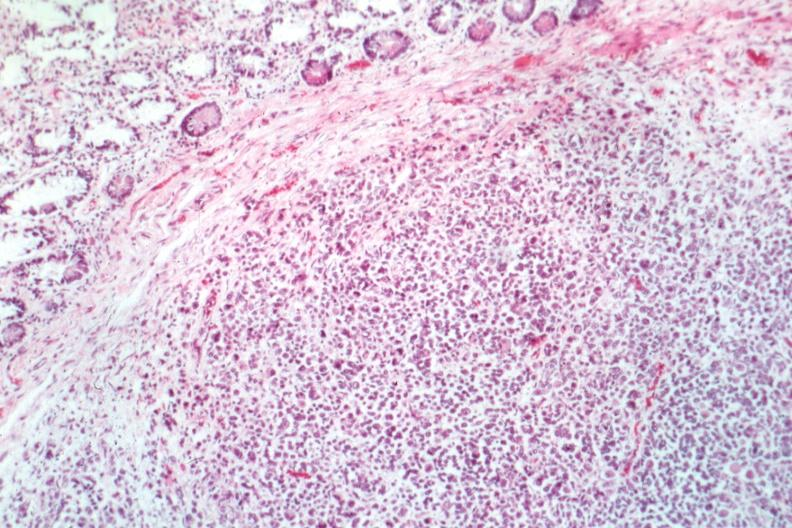what is present?
Answer the question using a single word or phrase. Gastrointestinal 